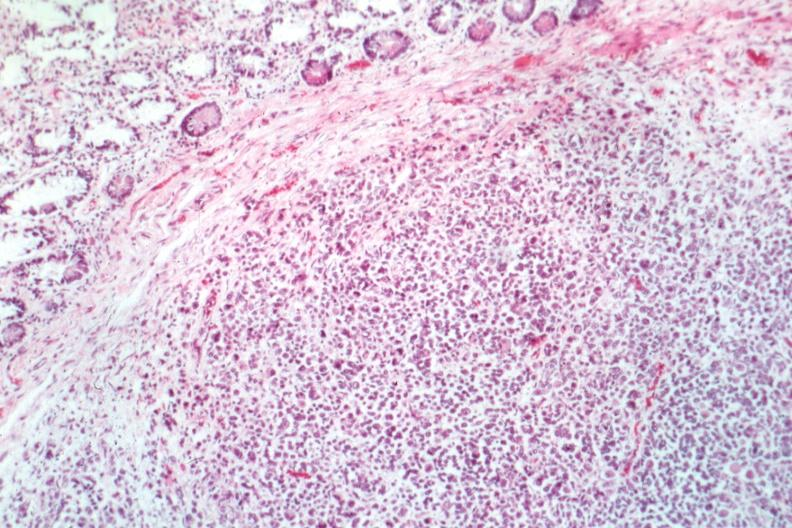what is present?
Answer the question using a single word or phrase. Gastrointestinal 